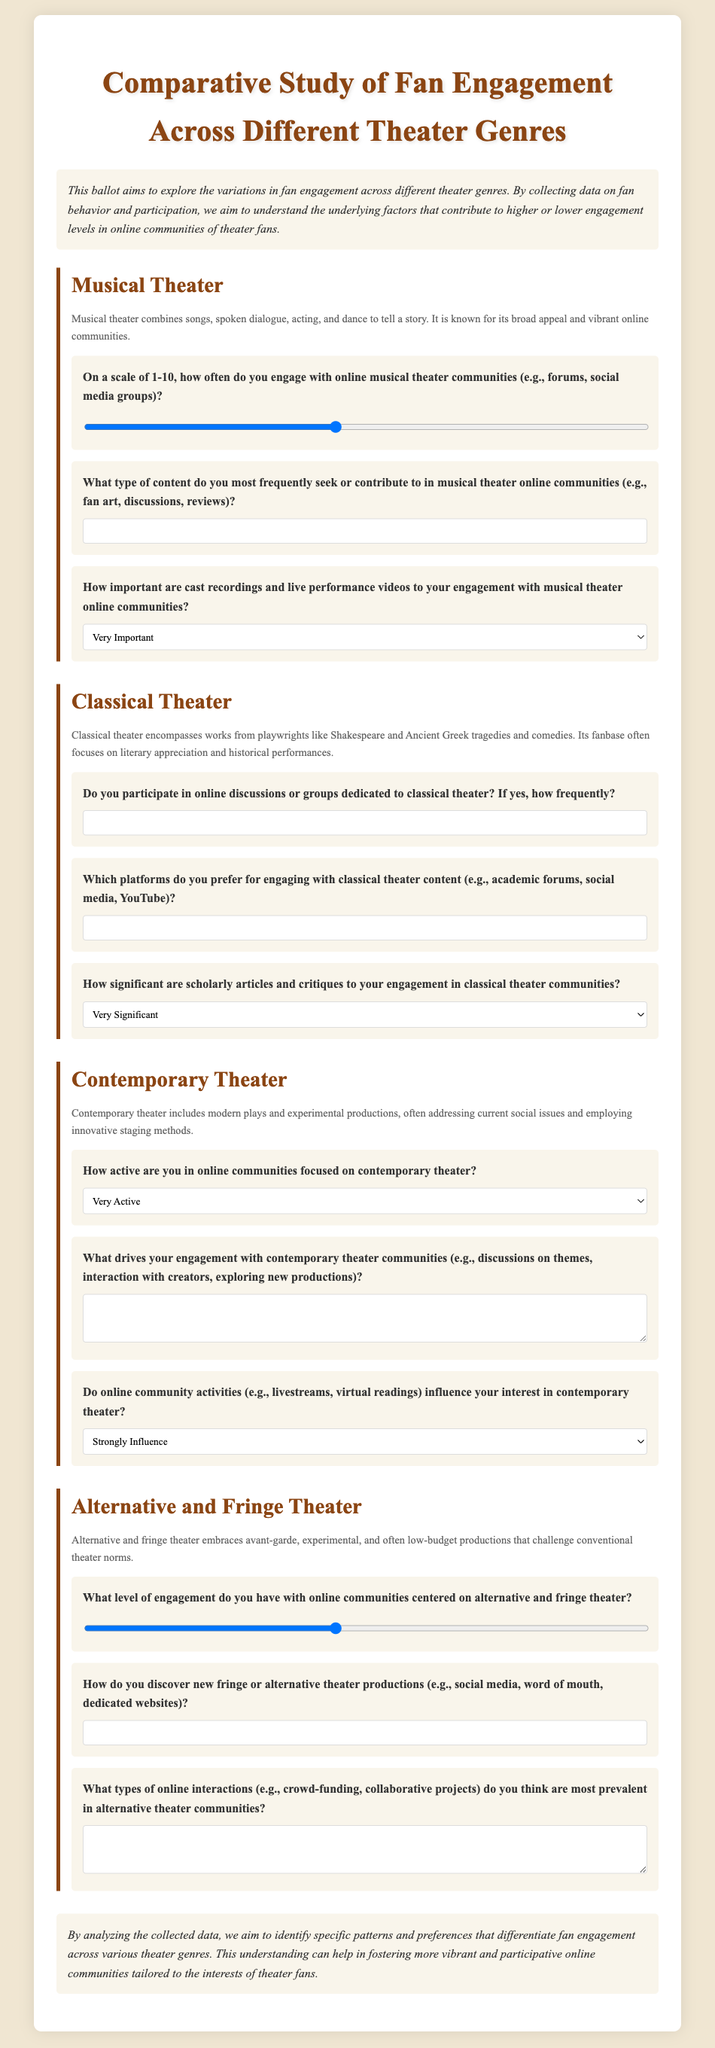How many sections are there in the ballot? The document contains a total of four sections, each dedicated to a different theater genre.
Answer: 4 What is the title of the ballot? The title of the ballot, as stated at the beginning, is "Comparative Study of Fan Engagement Across Different Theater Genres".
Answer: Comparative Study of Fan Engagement Across Different Theater Genres What type of content is most frequently sought in musical theater online communities? The document specifies that respondents can input their most frequently sought or contributed content in musical theater online communities, such as fan art, discussions, or reviews.
Answer: fan art, discussions, reviews How important are cast recordings to engagement with musical theater communities? The document presents a selection of options regarding the importance of cast recordings and live performance videos to engagement.
Answer: Very Important, Important, Somewhat Important, Not Important What drives engagement in contemporary theater communities? The document asks respondents to describe what drives their engagement with contemporary theater communities, such as discussions on themes or interaction with creators.
Answer: discussions on themes, interaction with creators What is the minimum engagement level for online communities of alternative and fringe theater? The ballot allows participants to rate their engagement level on a scale from 1 to 10, where 1 represents the minimum level of engagement.
Answer: 1 How do respondents discover new alternative theater productions? The document inquires how respondents discover new fringe or alternative theater productions, with options such as social media and word of mouth available for input.
Answer: social media, word of mouth, dedicated websites What is the significance of scholarly articles in classical theater engagement? The ballot asks how significant scholarly articles and critiques are to online engagement in classical theater communities, providing multiple response options.
Answer: Very Significant, Significant, Somewhat Significant, Not Significant How active are participants in online communities focused on contemporary theater? The section regarding contemporary theater includes a question that asks respondents to select their activity level, ranging from very active to not active at all.
Answer: Very Active, Somewhat Active, Not Very Active, Not Active At All 